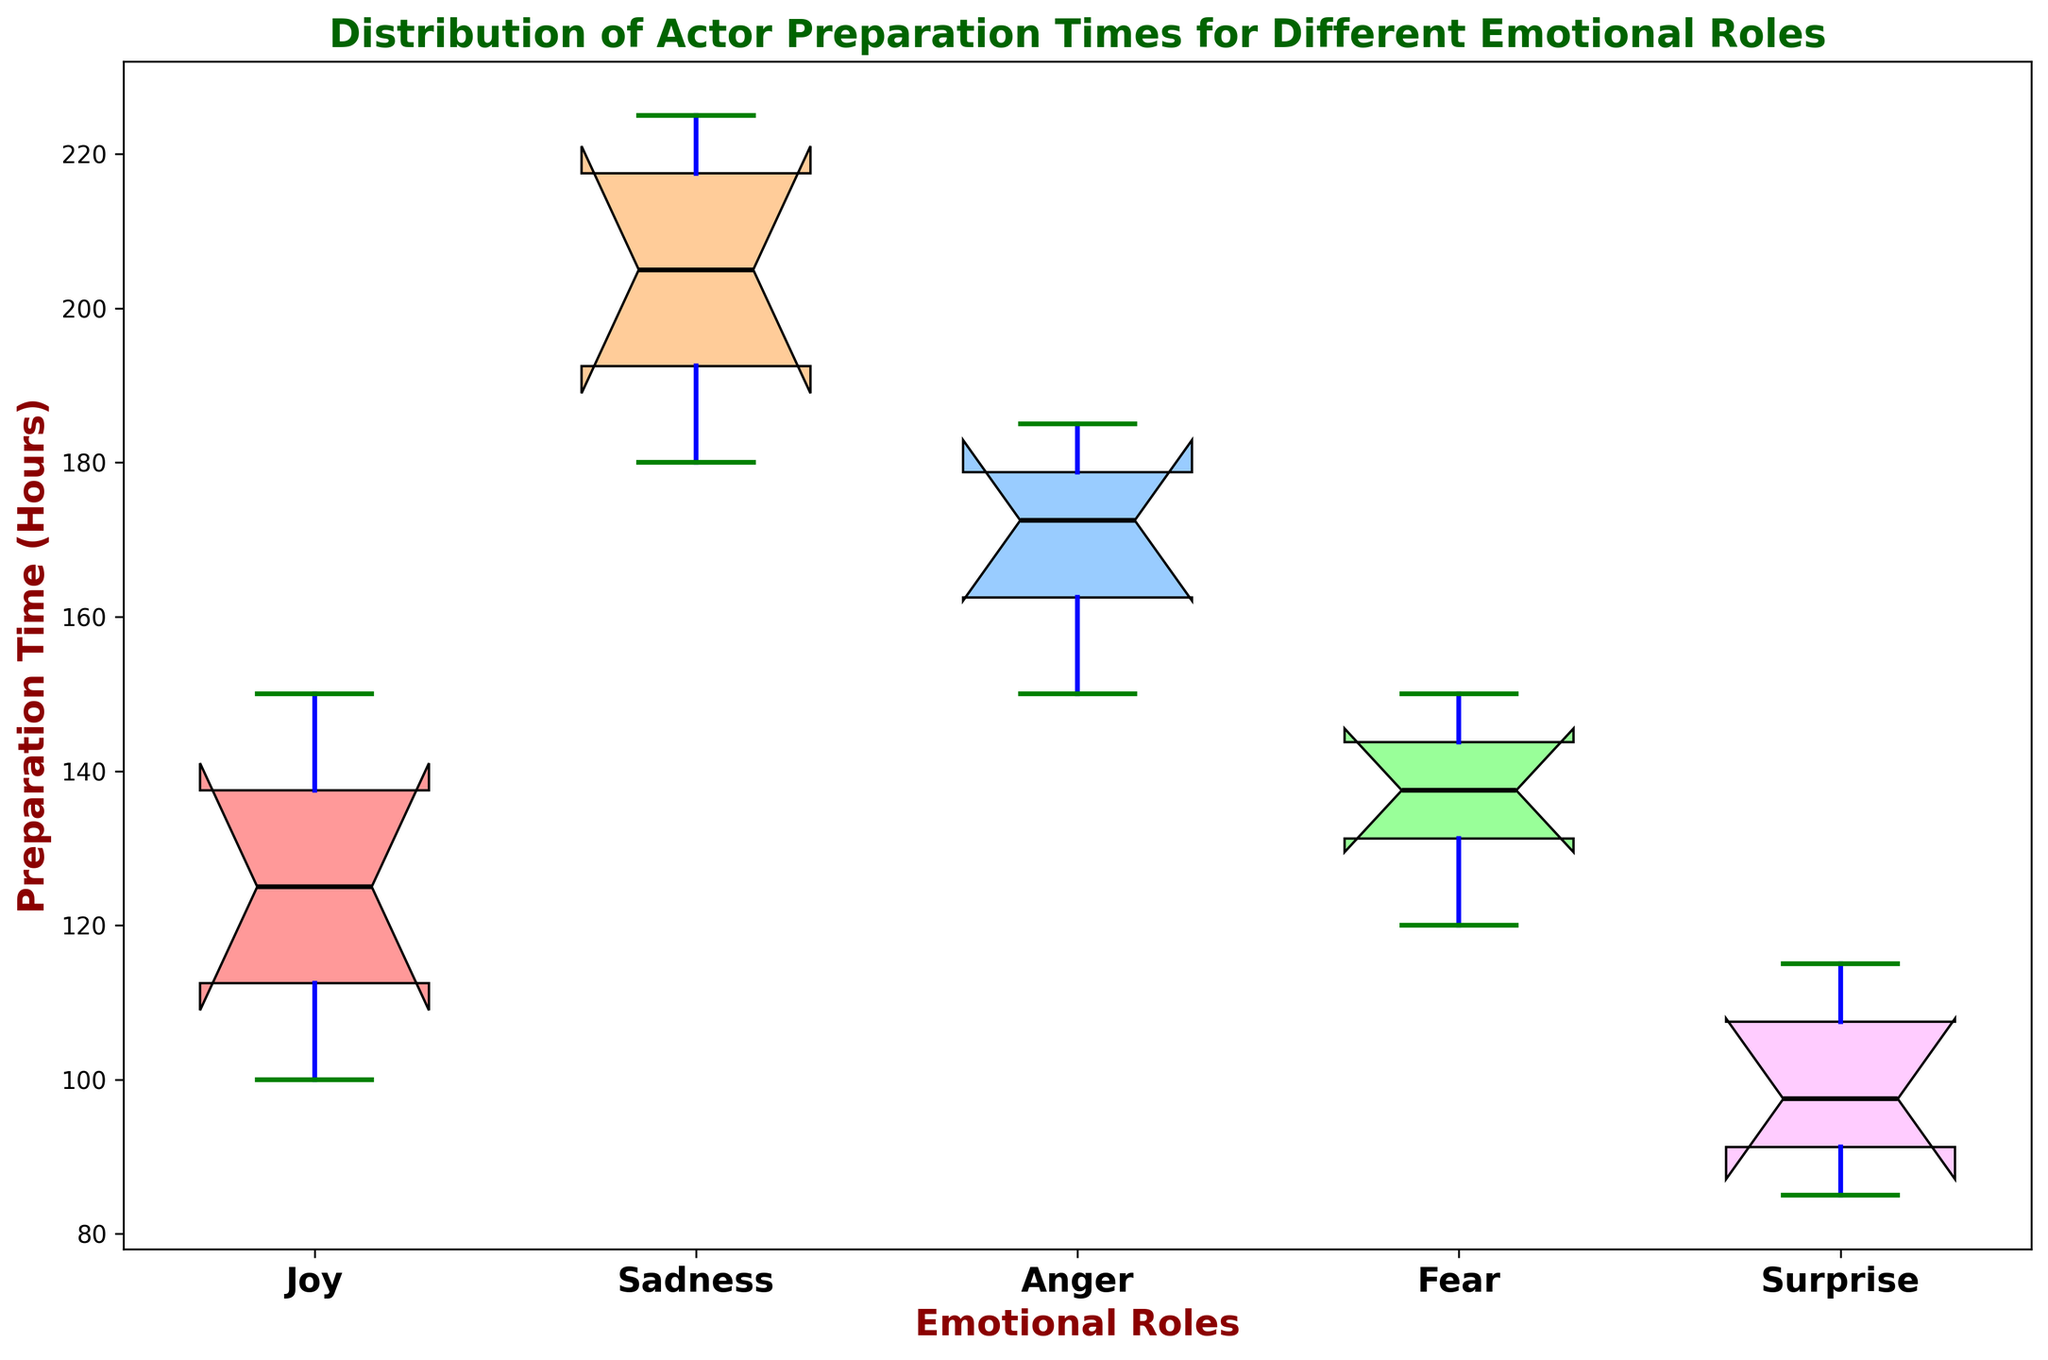Which emotional role has the highest median preparation time? To find the highest median preparation time, we look at the middle line within each box. For each role, compare these median values visually.
Answer: Sadness Which emotional role has the widest range of preparation times? The range is the difference between the maximum and minimum values, represented by the whiskers. Identify the role with the longest whiskers spread.
Answer: Sadness What is the median preparation time for the role of Joy? Locate the box for Joy and identify the middle line within it, which represents the median.
Answer: 120 hours Compare the interquartile range (IQR) of the preparation times for Anger and Fear. Which one is larger? The IQR is represented by the height of the box and is the distance between the lower and upper quartiles (Q1 and Q3). Visually compare the heights of the two boxes.
Answer: Anger Are there any outliers in the preparation time for the role of Surprise? Outliers are typically marked by individual points outside the whiskers. Check the box plot for Surprise for any points that lie outside the whiskers.
Answer: No Which role's preparation times are the most consistent (smallest variation)? The consistency can be inferred by looking at the box width and whiskers; the shorter they are, the more consistent the preparation times.
Answer: Surprise How does the median preparation time for Fear compare to the mean preparation time for Joy? First, identify the median for Fear from its box plot. The mean preparation time must be calculated: (120 + 110 + 150 + 100 +140 + 130) / 6 = 125. Now compare these two values.
Answer: Median of Fear > Mean of Joy For the role of Anger, what is the approximate interquartile range (IQR)? The IQR is calculated as Q3 - Q1, visually represented by the box height. Estimate the values at Q3 and Q1 and subtract them.
Answer: 25 hours What observations can be made about the critical acclaim scores with respect to different preparation times? Critical acclaim scores typically increase with longer preparation times, as seen with roles like Sadness and Fear. Roles such as Joy and Surprise, with shorter preparation times, have lower critical acclaim scores.
Answer: Higher preparation time tends to lead to higher critical acclaim Describe the shape of the distribution for Joy's preparation time. Is it skewed or symmetric? Look at the box plot for Joy. If the median is not centered within the box and whiskers are not of equal length, it indicates skewness. For Joy, the median is somewhat centered with almost similar whisker lengths.
Answer: Symmetric 